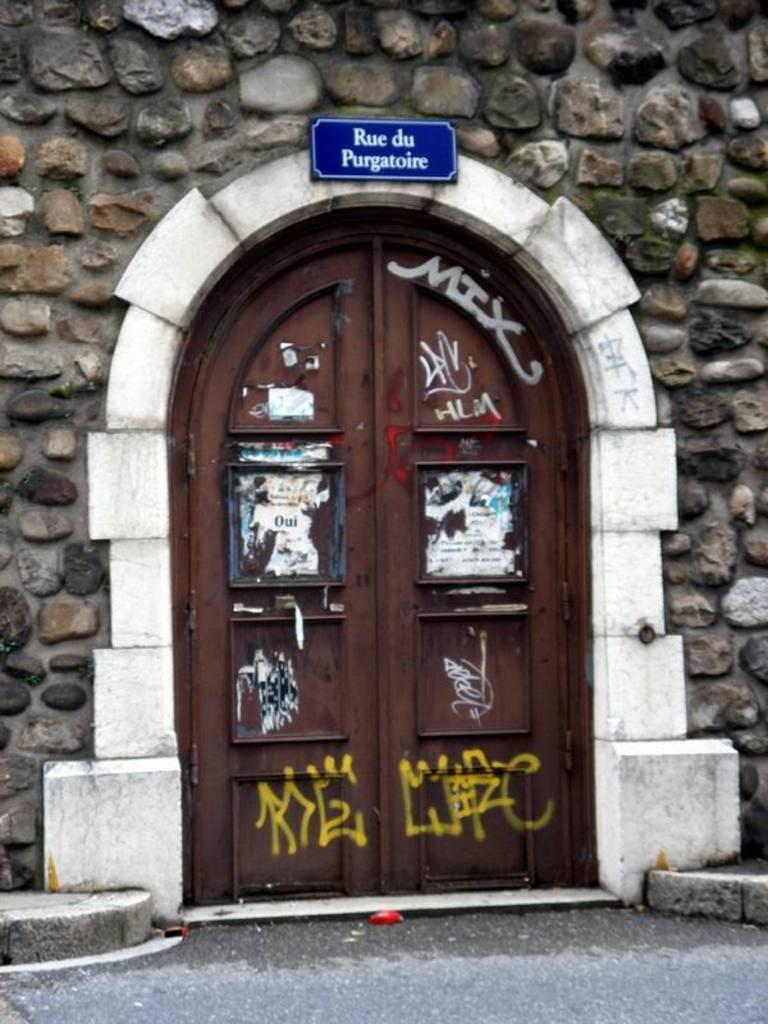What type of structure can be seen in the image? There is a stone wall in the image. What architectural feature is present near the stone wall? There is a white color arch in the image. What can be found within the arch? There is a brown color door in the image. What is on the door? The door has posters and paintings on it. What color is the board near the white color arch? There is a blue color board near the white color arch. How does the rake help in maintaining the white color arch in the image? There is no rake present in the image, and therefore it cannot be used to maintain the white color arch. 